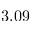Convert formula to latex. <formula><loc_0><loc_0><loc_500><loc_500>3 . 0 9</formula> 